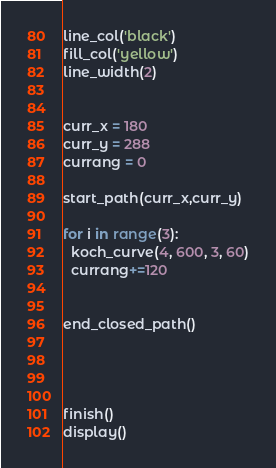Convert code to text. <code><loc_0><loc_0><loc_500><loc_500><_Python_>line_col('black')
fill_col('yellow')
line_width(2)


curr_x = 180
curr_y = 288
currang = 0

start_path(curr_x,curr_y)

for i in range(3):  
  koch_curve(4, 600, 3, 60)
  currang+=120


end_closed_path()




finish()
display()




</code> 